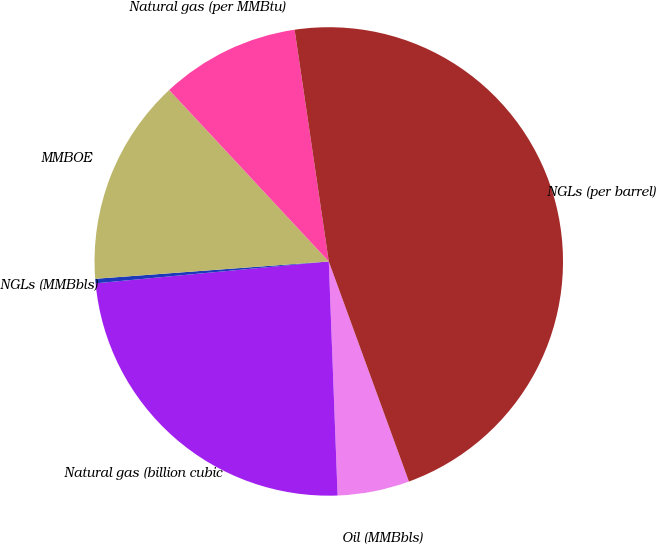Convert chart. <chart><loc_0><loc_0><loc_500><loc_500><pie_chart><fcel>Oil (MMBbls)<fcel>Natural gas (billion cubic<fcel>NGLs (MMBbls)<fcel>MMBOE<fcel>Natural gas (per MMBtu)<fcel>NGLs (per barrel)<nl><fcel>4.96%<fcel>24.11%<fcel>0.31%<fcel>14.25%<fcel>9.6%<fcel>46.77%<nl></chart> 